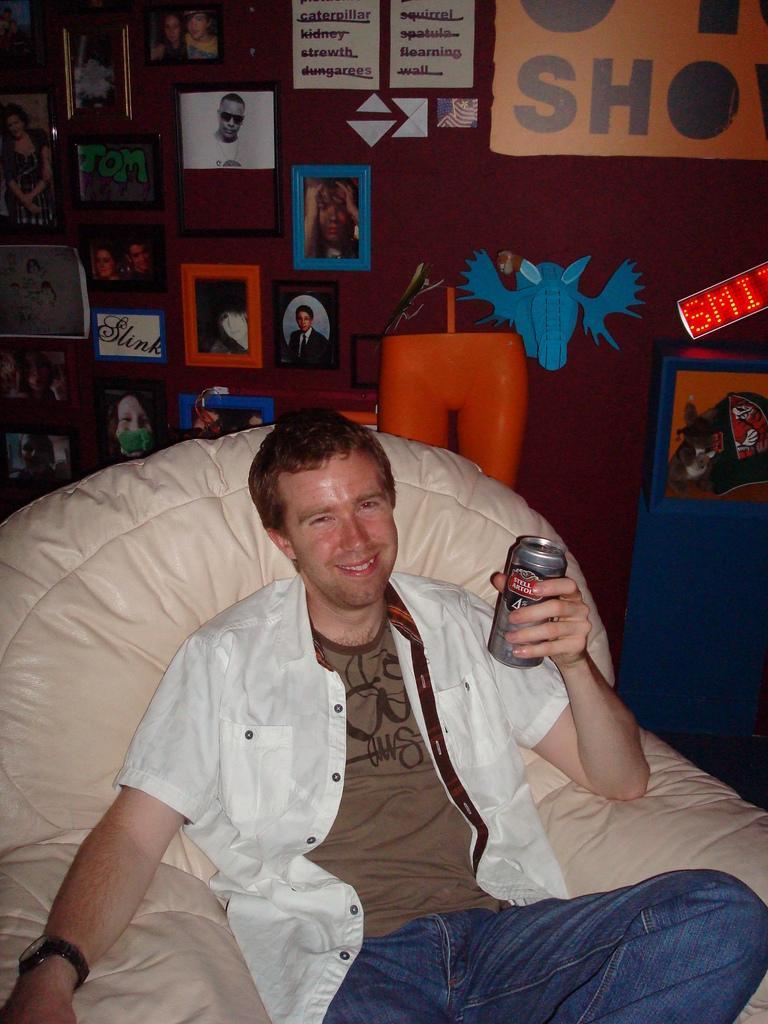Could you give a brief overview of what you see in this image? In this image we can see this person wearing white shirt, T-shirt and watch is holding a tin in his hands and sitting on the chair. In the background, we can see many photo frames and posters on the wall. 